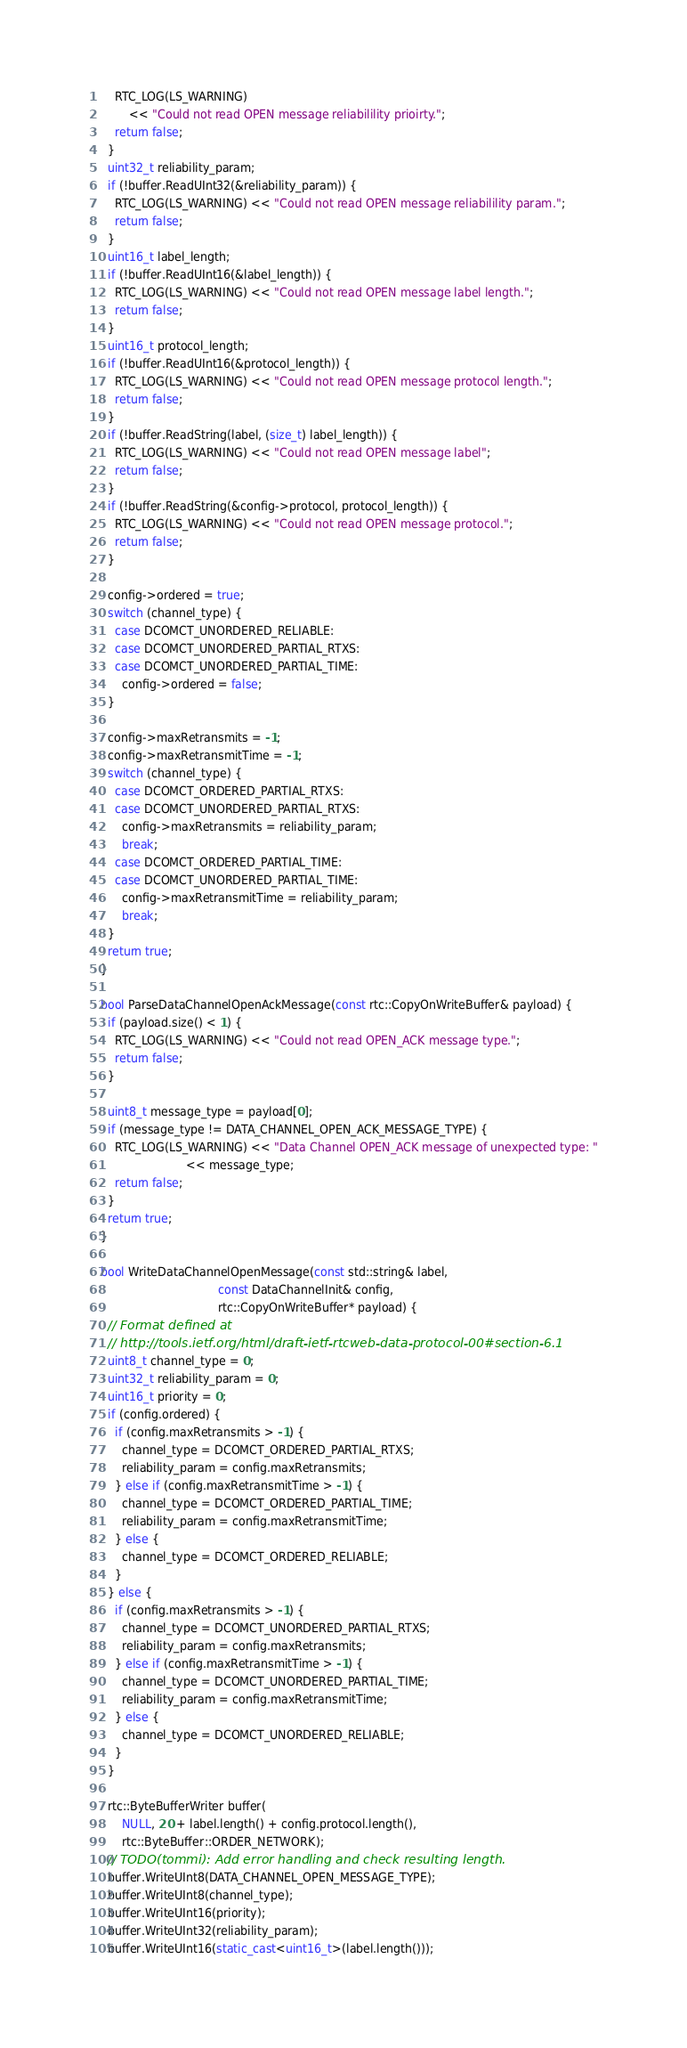<code> <loc_0><loc_0><loc_500><loc_500><_C++_>    RTC_LOG(LS_WARNING)
        << "Could not read OPEN message reliabilility prioirty.";
    return false;
  }
  uint32_t reliability_param;
  if (!buffer.ReadUInt32(&reliability_param)) {
    RTC_LOG(LS_WARNING) << "Could not read OPEN message reliabilility param.";
    return false;
  }
  uint16_t label_length;
  if (!buffer.ReadUInt16(&label_length)) {
    RTC_LOG(LS_WARNING) << "Could not read OPEN message label length.";
    return false;
  }
  uint16_t protocol_length;
  if (!buffer.ReadUInt16(&protocol_length)) {
    RTC_LOG(LS_WARNING) << "Could not read OPEN message protocol length.";
    return false;
  }
  if (!buffer.ReadString(label, (size_t) label_length)) {
    RTC_LOG(LS_WARNING) << "Could not read OPEN message label";
    return false;
  }
  if (!buffer.ReadString(&config->protocol, protocol_length)) {
    RTC_LOG(LS_WARNING) << "Could not read OPEN message protocol.";
    return false;
  }

  config->ordered = true;
  switch (channel_type) {
    case DCOMCT_UNORDERED_RELIABLE:
    case DCOMCT_UNORDERED_PARTIAL_RTXS:
    case DCOMCT_UNORDERED_PARTIAL_TIME:
      config->ordered = false;
  }

  config->maxRetransmits = -1;
  config->maxRetransmitTime = -1;
  switch (channel_type) {
    case DCOMCT_ORDERED_PARTIAL_RTXS:
    case DCOMCT_UNORDERED_PARTIAL_RTXS:
      config->maxRetransmits = reliability_param;
      break;
    case DCOMCT_ORDERED_PARTIAL_TIME:
    case DCOMCT_UNORDERED_PARTIAL_TIME:
      config->maxRetransmitTime = reliability_param;
      break;
  }
  return true;
}

bool ParseDataChannelOpenAckMessage(const rtc::CopyOnWriteBuffer& payload) {
  if (payload.size() < 1) {
    RTC_LOG(LS_WARNING) << "Could not read OPEN_ACK message type.";
    return false;
  }

  uint8_t message_type = payload[0];
  if (message_type != DATA_CHANNEL_OPEN_ACK_MESSAGE_TYPE) {
    RTC_LOG(LS_WARNING) << "Data Channel OPEN_ACK message of unexpected type: "
                        << message_type;
    return false;
  }
  return true;
}

bool WriteDataChannelOpenMessage(const std::string& label,
                                 const DataChannelInit& config,
                                 rtc::CopyOnWriteBuffer* payload) {
  // Format defined at
  // http://tools.ietf.org/html/draft-ietf-rtcweb-data-protocol-00#section-6.1
  uint8_t channel_type = 0;
  uint32_t reliability_param = 0;
  uint16_t priority = 0;
  if (config.ordered) {
    if (config.maxRetransmits > -1) {
      channel_type = DCOMCT_ORDERED_PARTIAL_RTXS;
      reliability_param = config.maxRetransmits;
    } else if (config.maxRetransmitTime > -1) {
      channel_type = DCOMCT_ORDERED_PARTIAL_TIME;
      reliability_param = config.maxRetransmitTime;
    } else {
      channel_type = DCOMCT_ORDERED_RELIABLE;
    }
  } else {
    if (config.maxRetransmits > -1) {
      channel_type = DCOMCT_UNORDERED_PARTIAL_RTXS;
      reliability_param = config.maxRetransmits;
    } else if (config.maxRetransmitTime > -1) {
      channel_type = DCOMCT_UNORDERED_PARTIAL_TIME;
      reliability_param = config.maxRetransmitTime;
    } else {
      channel_type = DCOMCT_UNORDERED_RELIABLE;
    }
  }

  rtc::ByteBufferWriter buffer(
      NULL, 20 + label.length() + config.protocol.length(),
      rtc::ByteBuffer::ORDER_NETWORK);
  // TODO(tommi): Add error handling and check resulting length.
  buffer.WriteUInt8(DATA_CHANNEL_OPEN_MESSAGE_TYPE);
  buffer.WriteUInt8(channel_type);
  buffer.WriteUInt16(priority);
  buffer.WriteUInt32(reliability_param);
  buffer.WriteUInt16(static_cast<uint16_t>(label.length()));</code> 